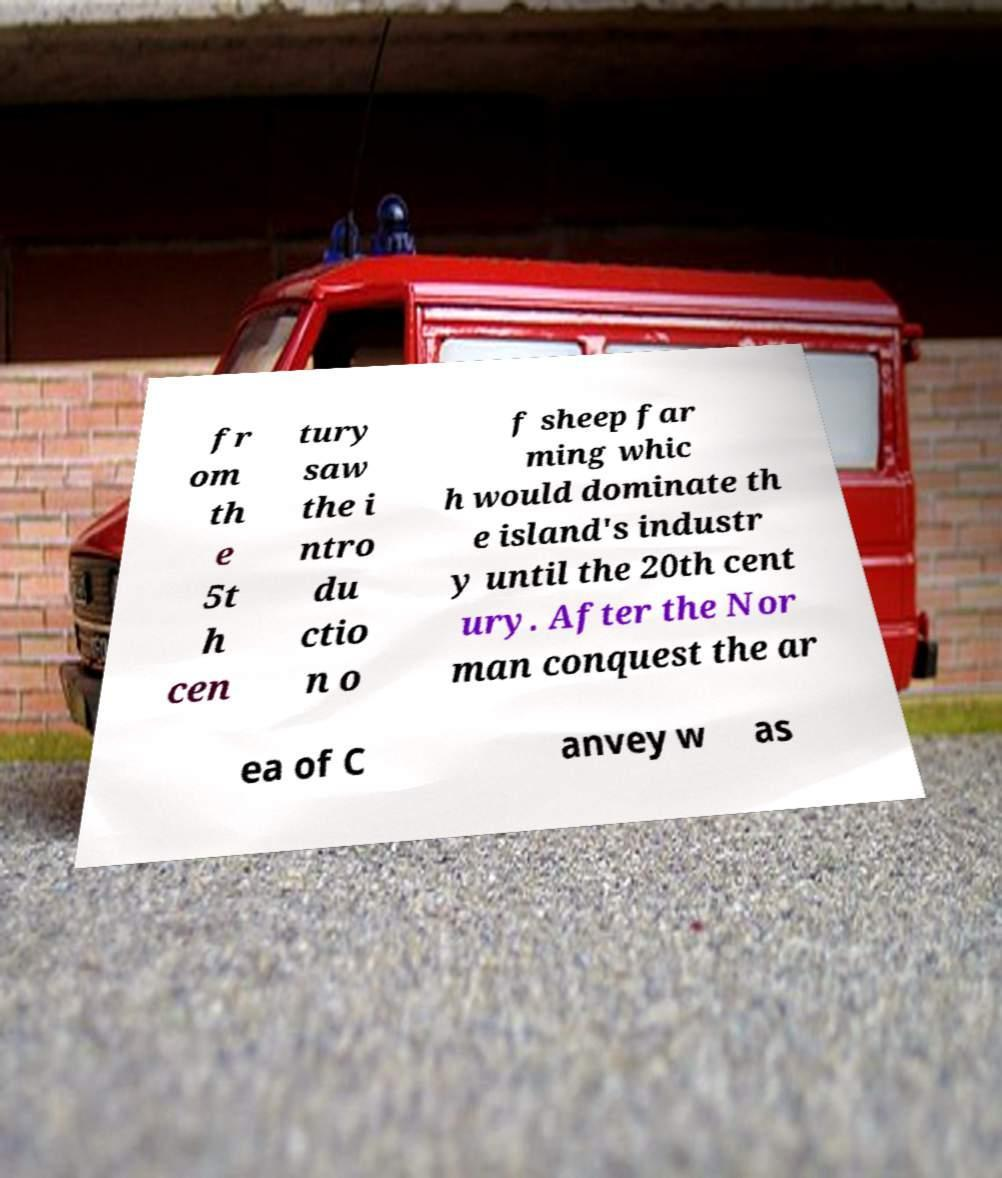Could you assist in decoding the text presented in this image and type it out clearly? fr om th e 5t h cen tury saw the i ntro du ctio n o f sheep far ming whic h would dominate th e island's industr y until the 20th cent ury. After the Nor man conquest the ar ea of C anvey w as 